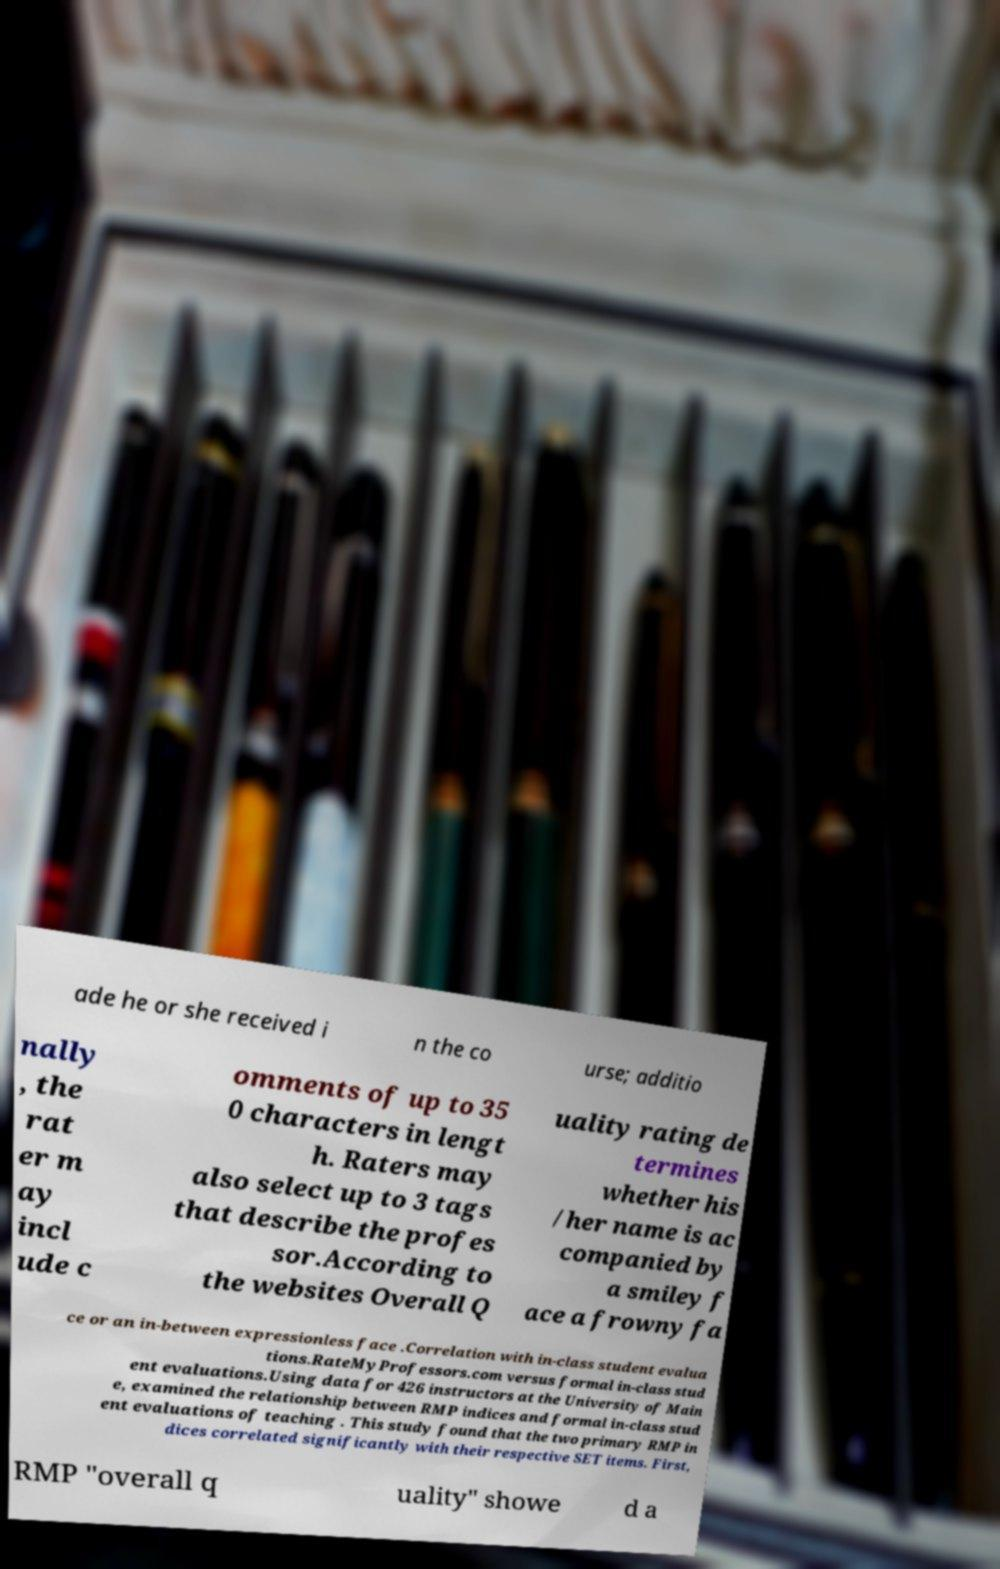Can you read and provide the text displayed in the image?This photo seems to have some interesting text. Can you extract and type it out for me? ade he or she received i n the co urse; additio nally , the rat er m ay incl ude c omments of up to 35 0 characters in lengt h. Raters may also select up to 3 tags that describe the profes sor.According to the websites Overall Q uality rating de termines whether his /her name is ac companied by a smiley f ace a frowny fa ce or an in-between expressionless face .Correlation with in-class student evalua tions.RateMyProfessors.com versus formal in-class stud ent evaluations.Using data for 426 instructors at the University of Main e, examined the relationship between RMP indices and formal in-class stud ent evaluations of teaching . This study found that the two primary RMP in dices correlated significantly with their respective SET items. First, RMP "overall q uality" showe d a 